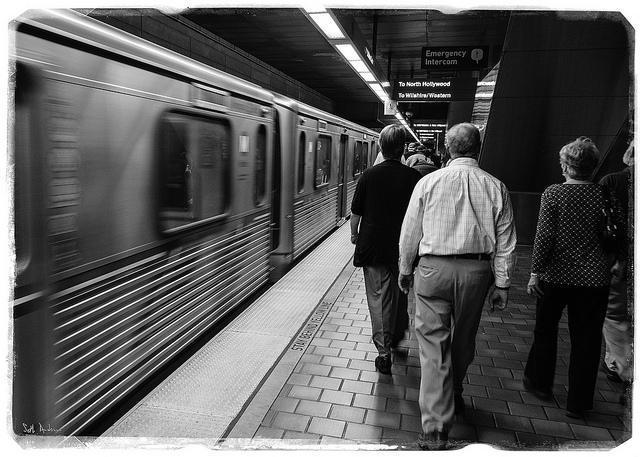How many people can you see?
Give a very brief answer. 4. 